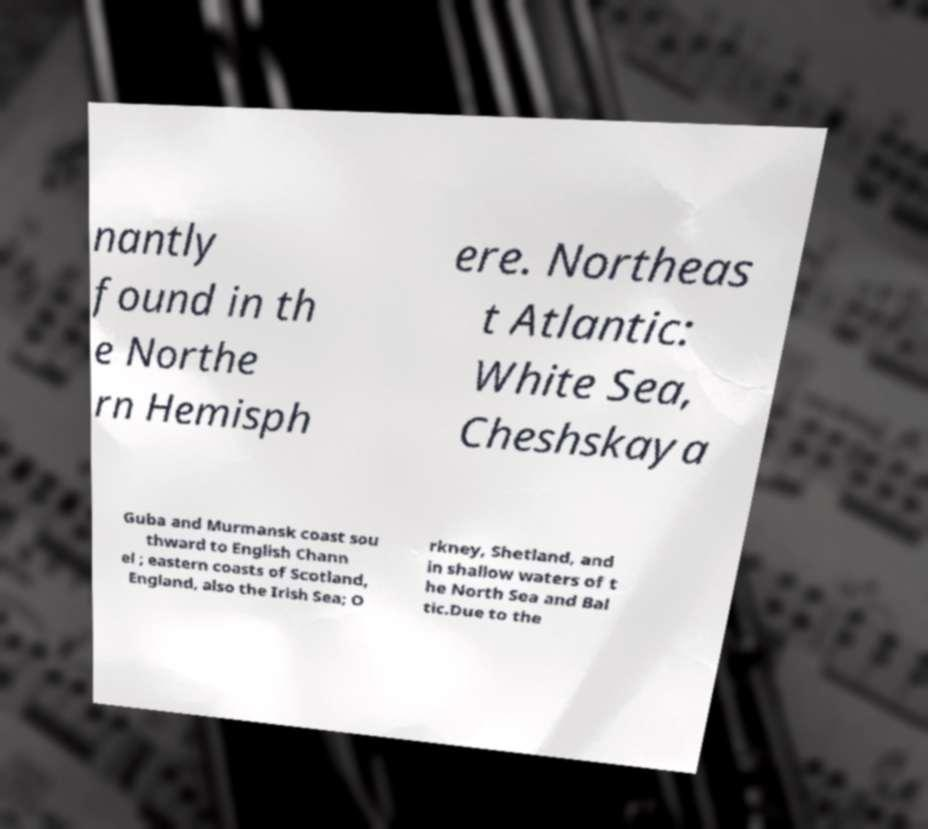What messages or text are displayed in this image? I need them in a readable, typed format. nantly found in th e Northe rn Hemisph ere. Northeas t Atlantic: White Sea, Cheshskaya Guba and Murmansk coast sou thward to English Chann el ; eastern coasts of Scotland, England, also the Irish Sea; O rkney, Shetland, and in shallow waters of t he North Sea and Bal tic.Due to the 